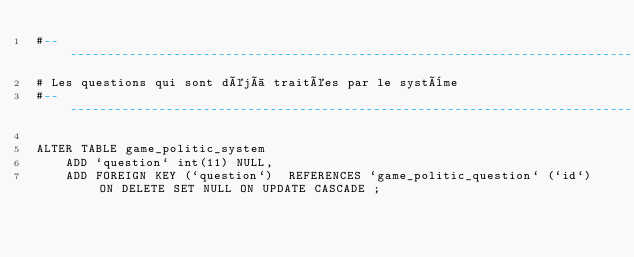<code> <loc_0><loc_0><loc_500><loc_500><_SQL_>#------------------------------------------------------------------------------
# Les questions qui sont déjà traitées par le système
#------------------------------------------------------------------------------

ALTER TABLE game_politic_system
    ADD `question` int(11) NULL,
    ADD FOREIGN KEY (`question`)  REFERENCES `game_politic_question` (`id`) ON DELETE SET NULL ON UPDATE CASCADE ;</code> 